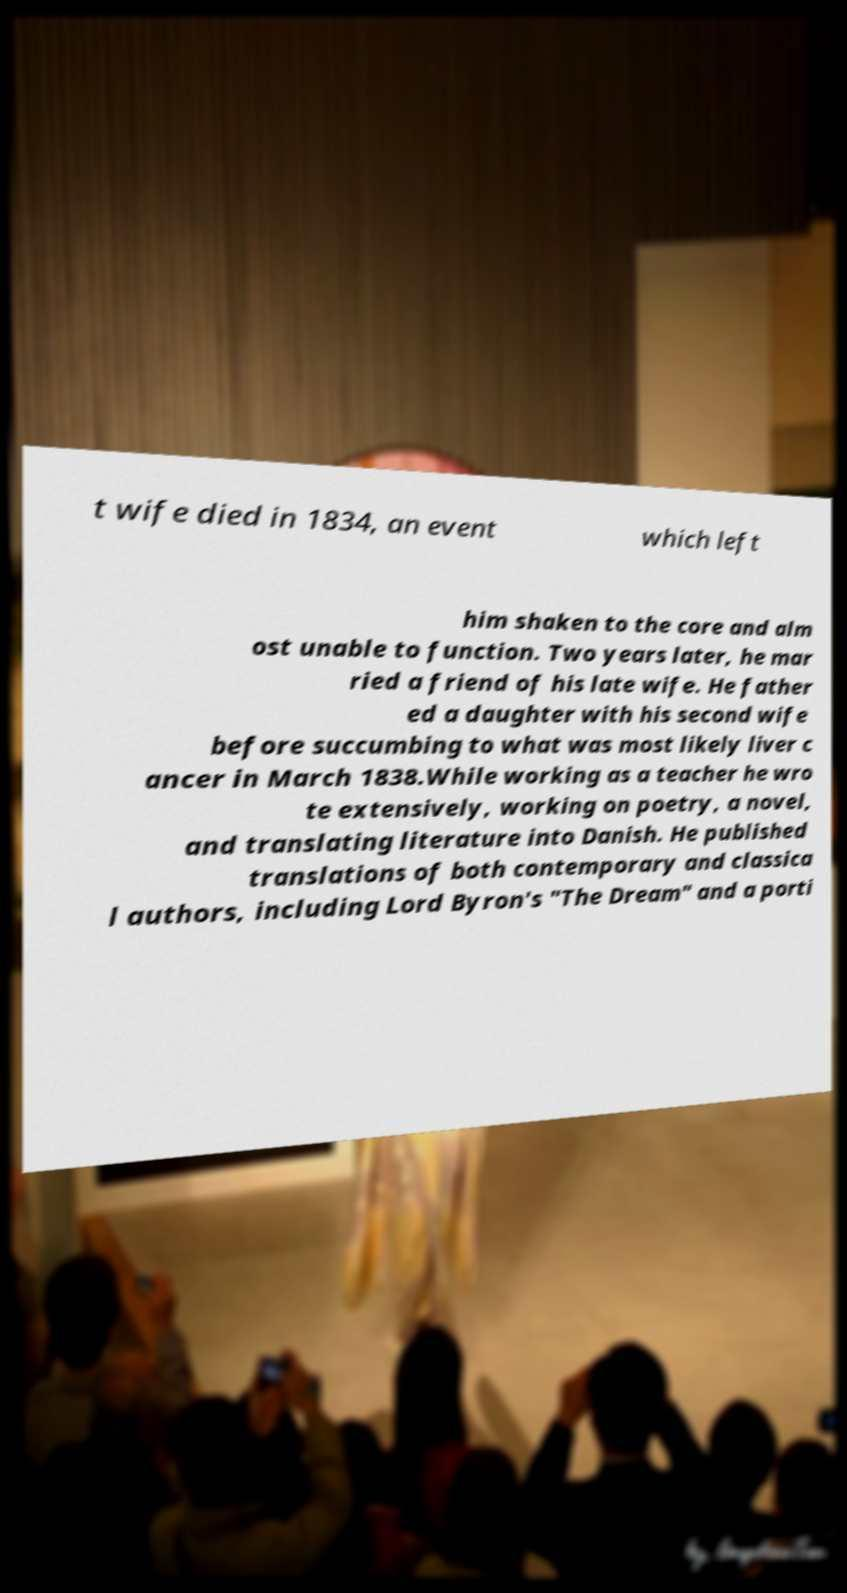Can you accurately transcribe the text from the provided image for me? t wife died in 1834, an event which left him shaken to the core and alm ost unable to function. Two years later, he mar ried a friend of his late wife. He father ed a daughter with his second wife before succumbing to what was most likely liver c ancer in March 1838.While working as a teacher he wro te extensively, working on poetry, a novel, and translating literature into Danish. He published translations of both contemporary and classica l authors, including Lord Byron's "The Dream" and a porti 